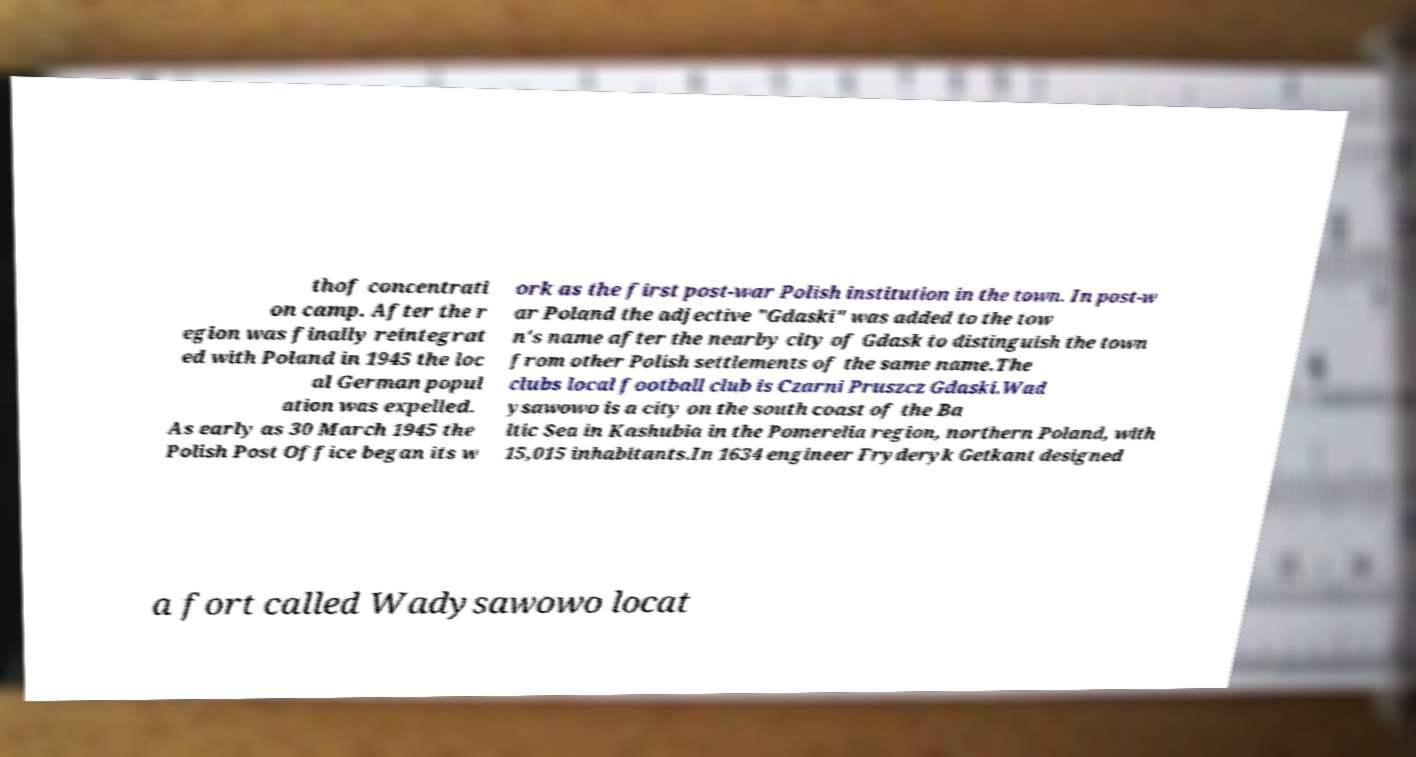I need the written content from this picture converted into text. Can you do that? thof concentrati on camp. After the r egion was finally reintegrat ed with Poland in 1945 the loc al German popul ation was expelled. As early as 30 March 1945 the Polish Post Office began its w ork as the first post-war Polish institution in the town. In post-w ar Poland the adjective "Gdaski" was added to the tow n's name after the nearby city of Gdask to distinguish the town from other Polish settlements of the same name.The clubs local football club is Czarni Pruszcz Gdaski.Wad ysawowo is a city on the south coast of the Ba ltic Sea in Kashubia in the Pomerelia region, northern Poland, with 15,015 inhabitants.In 1634 engineer Fryderyk Getkant designed a fort called Wadysawowo locat 